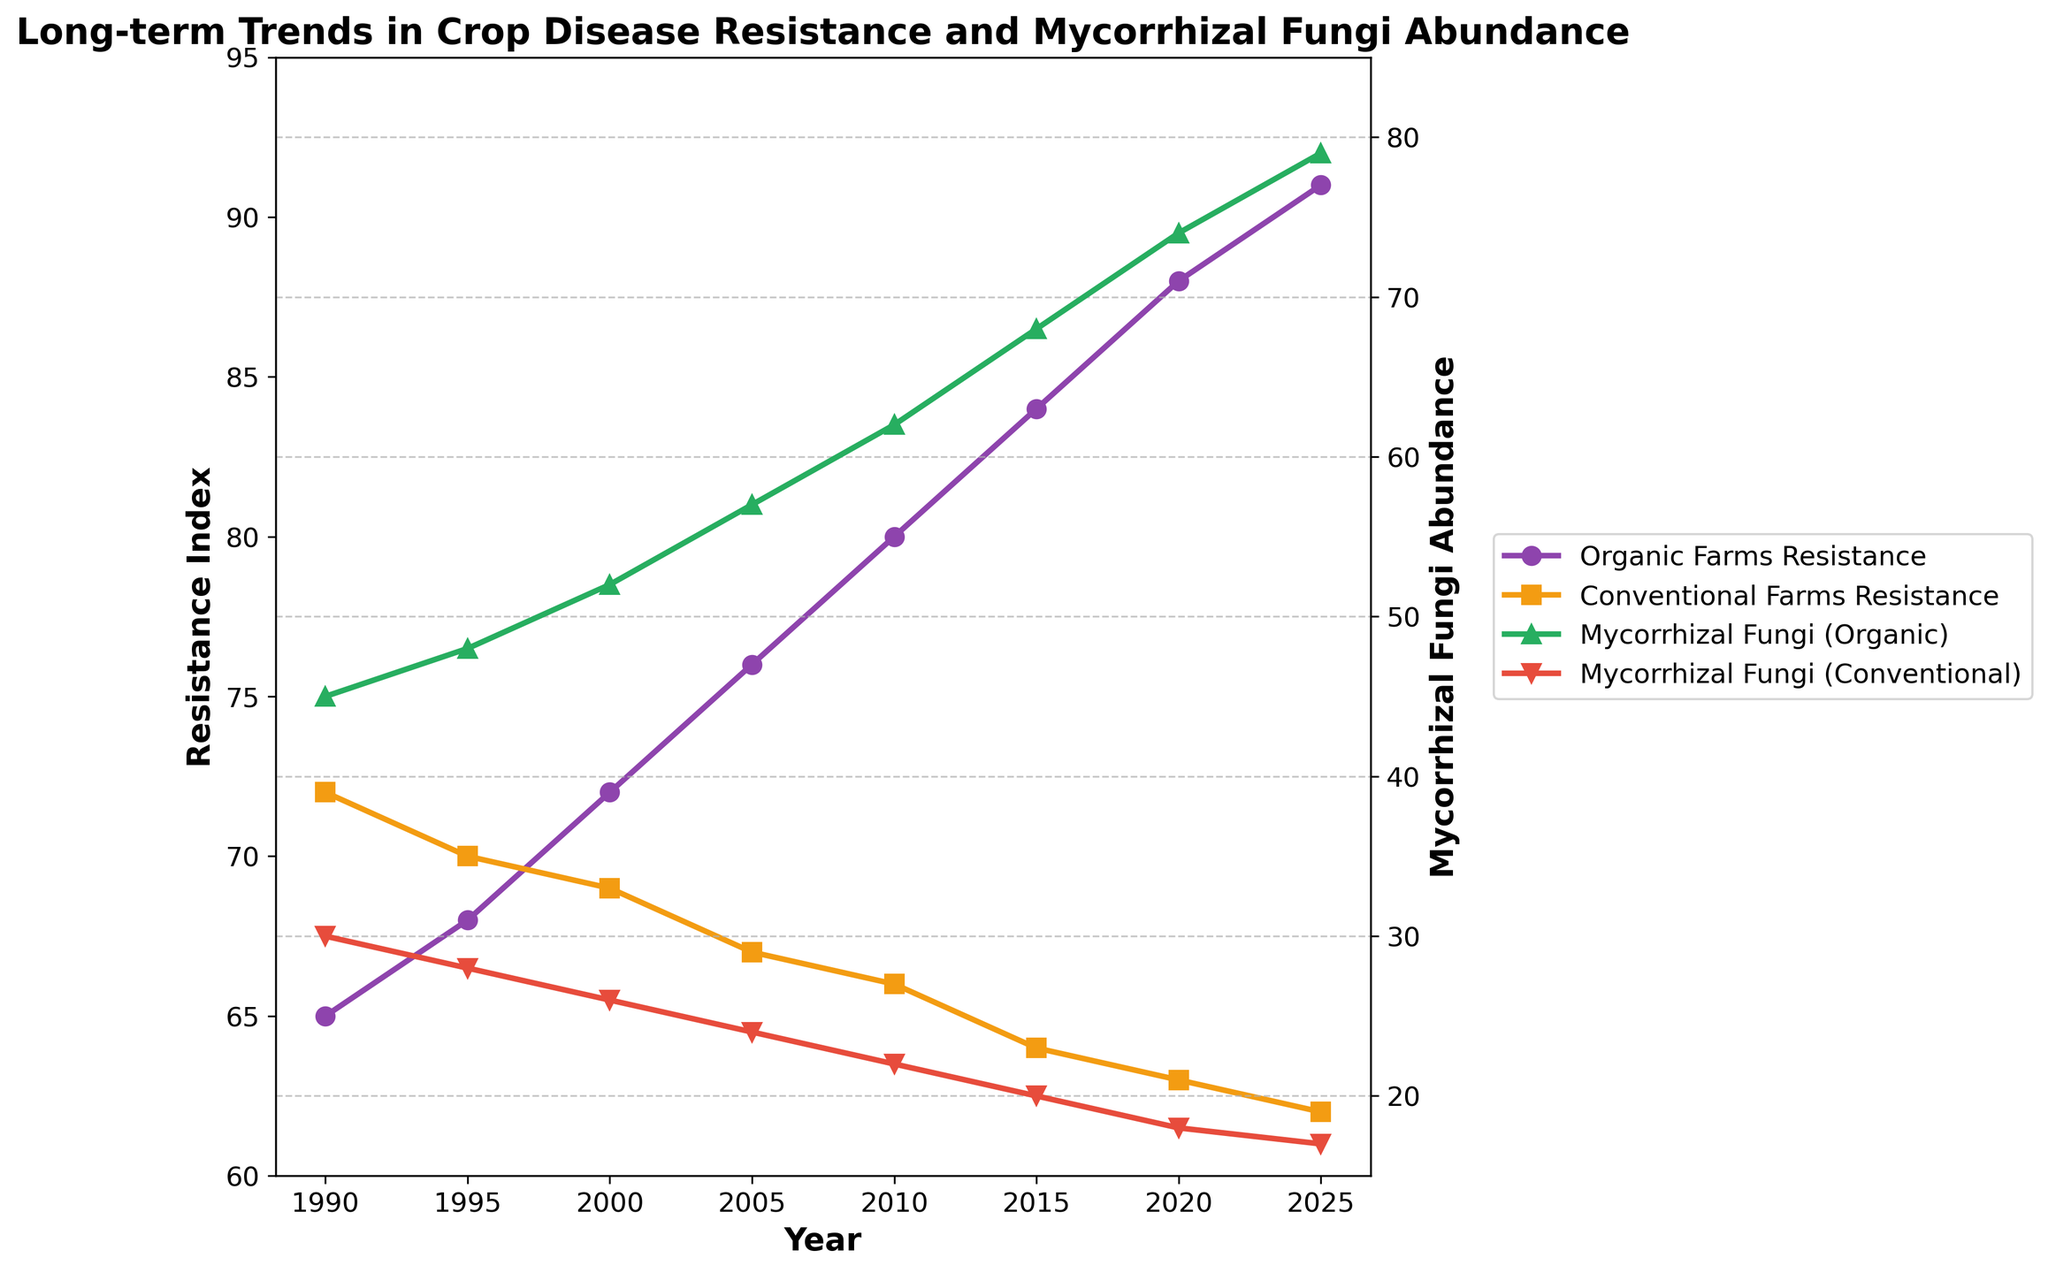What was the magnitude of increase in the Resistance Index for Organic Farms from 1990 to 2025? Subtract the Resistance Index of Organic Farms in 1990 from the index in 2025: 91 (2025) - 65 (1990) = 26.
Answer: 26 In which year did Conventional Farms and Organic Farms have the closest Resistance Index, and what was the difference? Compare the Resistance Indices of Conventional and Organic Farms for each year to find the smallest difference. The closest was in 1995: 70 (Conventional) - 68(Organic) = 2.
Answer: 1995, 2 How does the Mycorrhizal Fungi Abundance trend differ between Organic and Conventional Farms from 1990 to 2025? Organic farms show a steady increase in Mycorrhizal Fungi Abundance from 45 to 79, whereas Conventional farms show a steady decrease from 30 to 17.
Answer: Increasing for Organic, Decreasing for Conventional What is the average Mycorrhizal Fungi Abundance for Organic Farms over the entire period? Add the Mycorrhizal Fungi Abundance for Organic Farms from all years and divide by the number of years: (45+48+52+57+62+68+74+79)/8 = 485/8 = 60.625.
Answer: 60.625 Which type of farm had a higher Resistance Index in 2020, and by how much? Compare the Resistance Index for each type of farm in 2020: Organic (88) vs. Conventional (63). The difference is 88 - 63 = 25.
Answer: Organic, by 25 What can be inferred visually about the relationship between Resistance Index and Mycorrhizal Fungi Abundance in Organic Farms over the years? Visually, both the Resistance Index and Mycorrhizal Fungi Abundance in Organic Farms show an increasing trend, suggesting a positive correlation.
Answer: Positive correlation In what year did the Resistance Index for Organic Farms first surpass 80? Check the year when Organic Farms' Resistance Index first exceeds 80. This occurs in 2010 when the index reaches 80.
Answer: 2010 Which year shows the greatest divergence in Mycorrhizal Fungi Abundance between Organic and Conventional Farms? Find the year with the largest difference in Mycorrhizal Fungi Abundance. In 2025, it's 79 (Organic) - 17 (Conventional) = 62.
Answer: 2025 What is depicted by the green and red lines on the graph? The green line represents the Mycorrhizal Fungi Abundance in Organic Farms, while the red line represents the Mycorrhizal Fungi Abundance in Conventional Farms.
Answer: Mycorrhizal Fungi Abundance in Organic (green) and Conventional (red) Between 2000 and 2010, which type of farm shows a significant change in Resistance Index, and what is the magnitude of that change? Calculate the change for both farm types: Organic increases from 72 to 80, which is 80 - 72 = 8. Conventional decreases from 69 to 66, which is 69 - 66 = 3. The Organic change is greater.
Answer: Organic, magnitude 8 